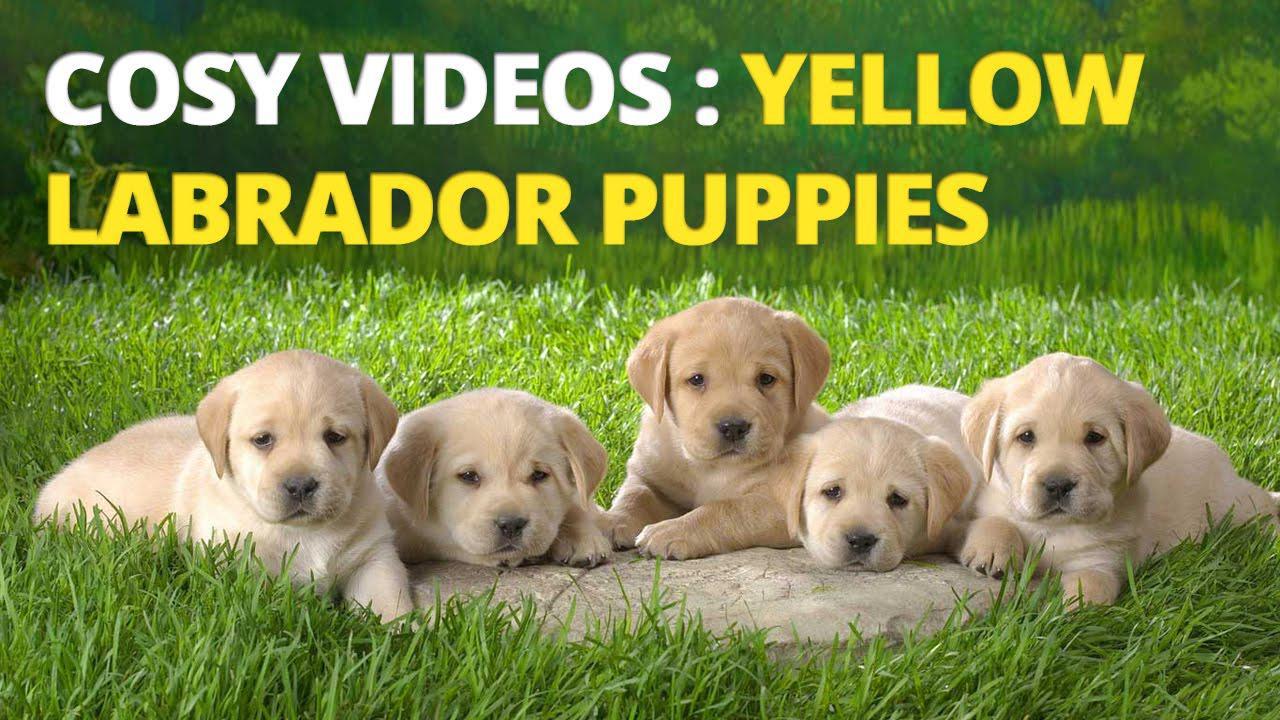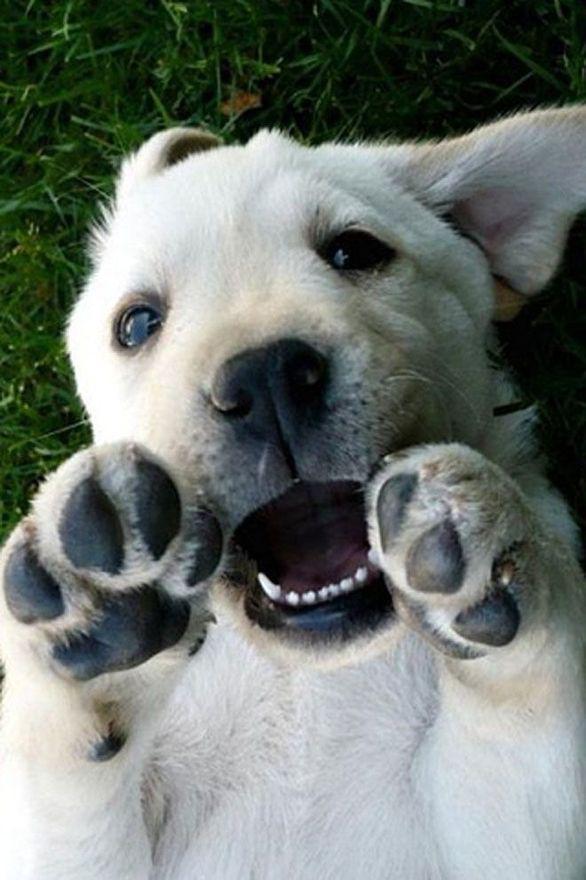The first image is the image on the left, the second image is the image on the right. For the images shown, is this caption "Two little dogs are shown, one with a toy." true? Answer yes or no. No. The first image is the image on the left, the second image is the image on the right. Given the left and right images, does the statement "Right image shows a pale puppy with some kind of play-thing." hold true? Answer yes or no. No. 